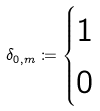<formula> <loc_0><loc_0><loc_500><loc_500>\delta _ { 0 , m } \coloneqq \begin{cases} 1 & \\ 0 & \end{cases}</formula> 